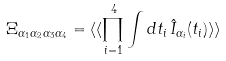<formula> <loc_0><loc_0><loc_500><loc_500>\Xi _ { \alpha _ { 1 } \alpha _ { 2 } \alpha _ { 3 } \alpha _ { 4 } } = \langle \langle \prod _ { i = 1 } ^ { 4 } \int d t _ { i } \, \hat { I } _ { \alpha _ { i } } ( t _ { i } ) \rangle \rangle</formula> 